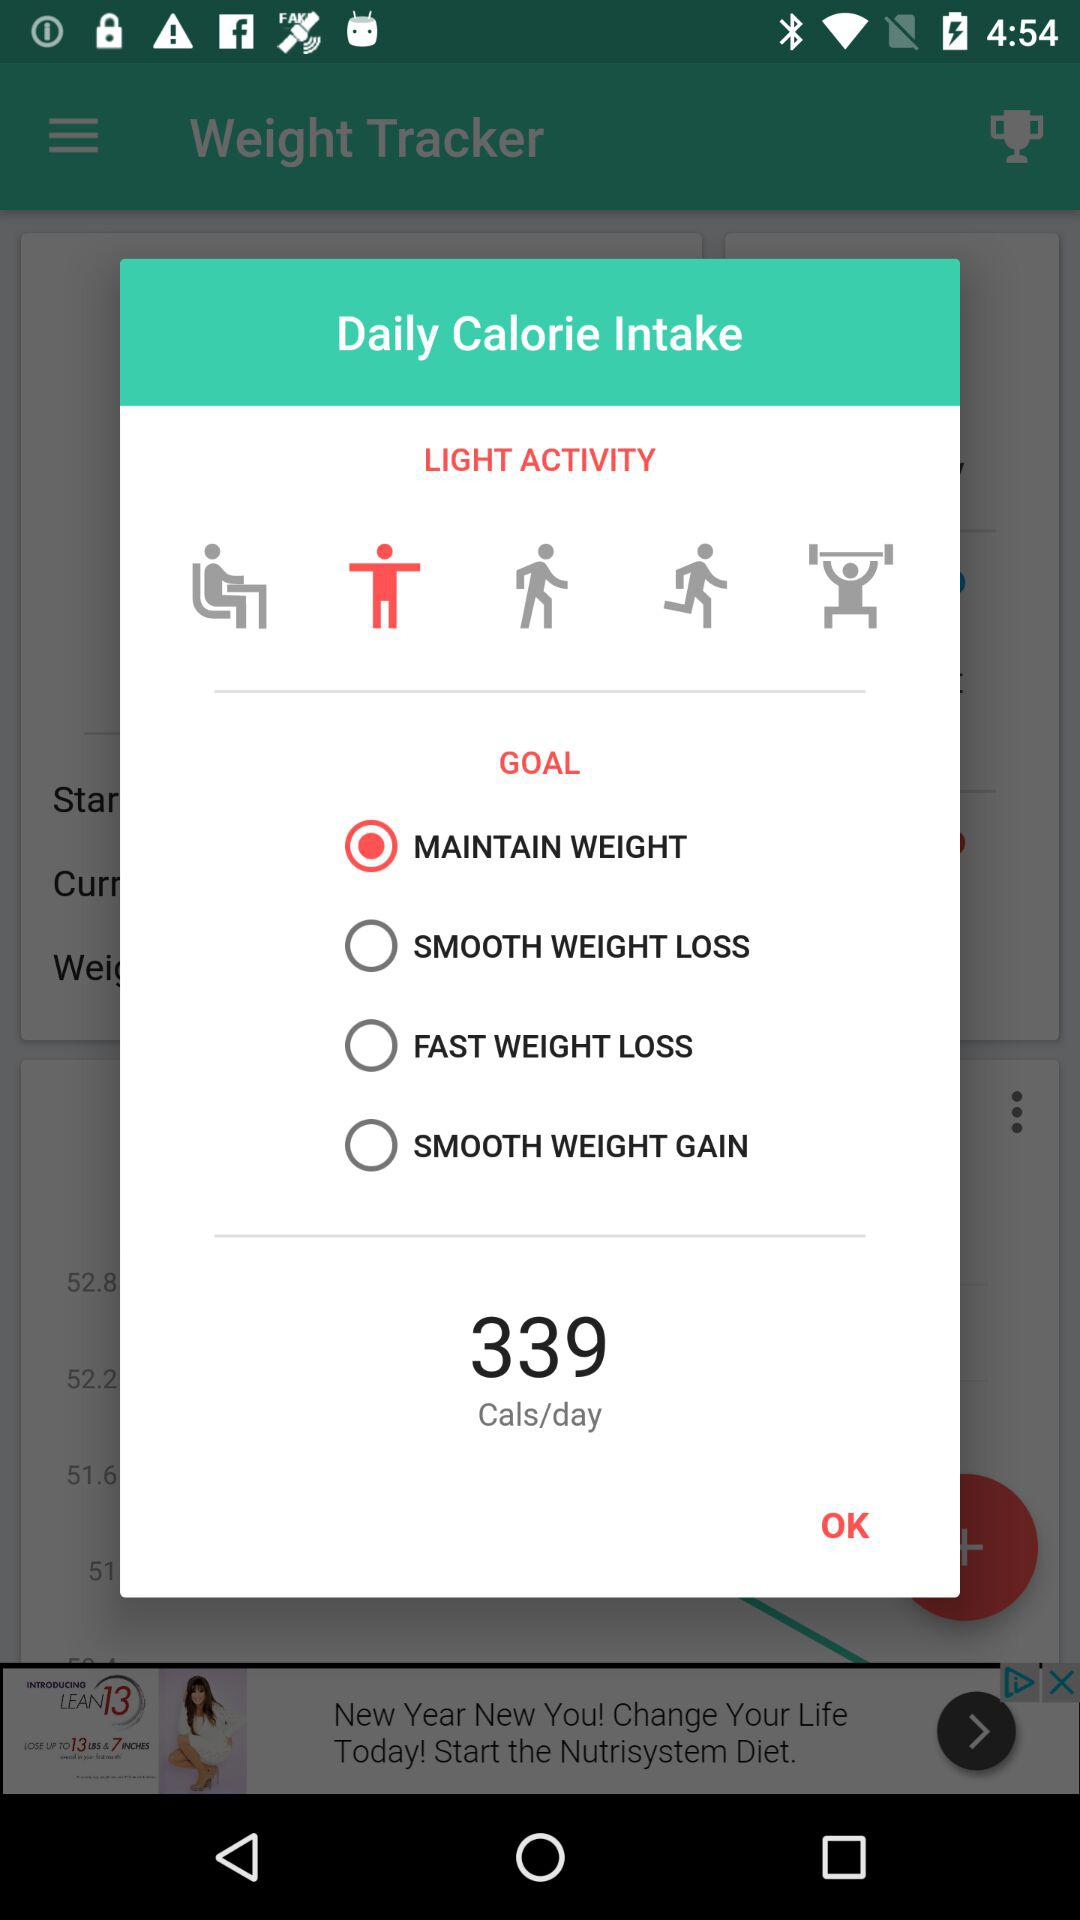What is the name of the application? The name of the application is "Weight Tracker". 